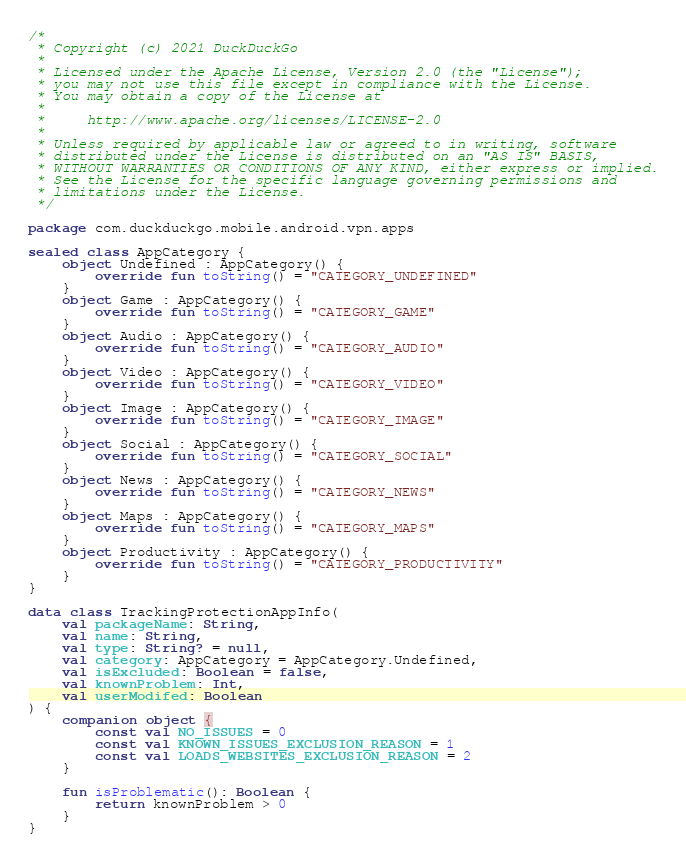<code> <loc_0><loc_0><loc_500><loc_500><_Kotlin_>/*
 * Copyright (c) 2021 DuckDuckGo
 *
 * Licensed under the Apache License, Version 2.0 (the "License");
 * you may not use this file except in compliance with the License.
 * You may obtain a copy of the License at
 *
 *     http://www.apache.org/licenses/LICENSE-2.0
 *
 * Unless required by applicable law or agreed to in writing, software
 * distributed under the License is distributed on an "AS IS" BASIS,
 * WITHOUT WARRANTIES OR CONDITIONS OF ANY KIND, either express or implied.
 * See the License for the specific language governing permissions and
 * limitations under the License.
 */

package com.duckduckgo.mobile.android.vpn.apps

sealed class AppCategory {
    object Undefined : AppCategory() {
        override fun toString() = "CATEGORY_UNDEFINED"
    }
    object Game : AppCategory() {
        override fun toString() = "CATEGORY_GAME"
    }
    object Audio : AppCategory() {
        override fun toString() = "CATEGORY_AUDIO"
    }
    object Video : AppCategory() {
        override fun toString() = "CATEGORY_VIDEO"
    }
    object Image : AppCategory() {
        override fun toString() = "CATEGORY_IMAGE"
    }
    object Social : AppCategory() {
        override fun toString() = "CATEGORY_SOCIAL"
    }
    object News : AppCategory() {
        override fun toString() = "CATEGORY_NEWS"
    }
    object Maps : AppCategory() {
        override fun toString() = "CATEGORY_MAPS"
    }
    object Productivity : AppCategory() {
        override fun toString() = "CATEGORY_PRODUCTIVITY"
    }
}

data class TrackingProtectionAppInfo(
    val packageName: String,
    val name: String,
    val type: String? = null,
    val category: AppCategory = AppCategory.Undefined,
    val isExcluded: Boolean = false,
    val knownProblem: Int,
    val userModifed: Boolean
) {
    companion object {
        const val NO_ISSUES = 0
        const val KNOWN_ISSUES_EXCLUSION_REASON = 1
        const val LOADS_WEBSITES_EXCLUSION_REASON = 2
    }

    fun isProblematic(): Boolean {
        return knownProblem > 0
    }
}
</code> 